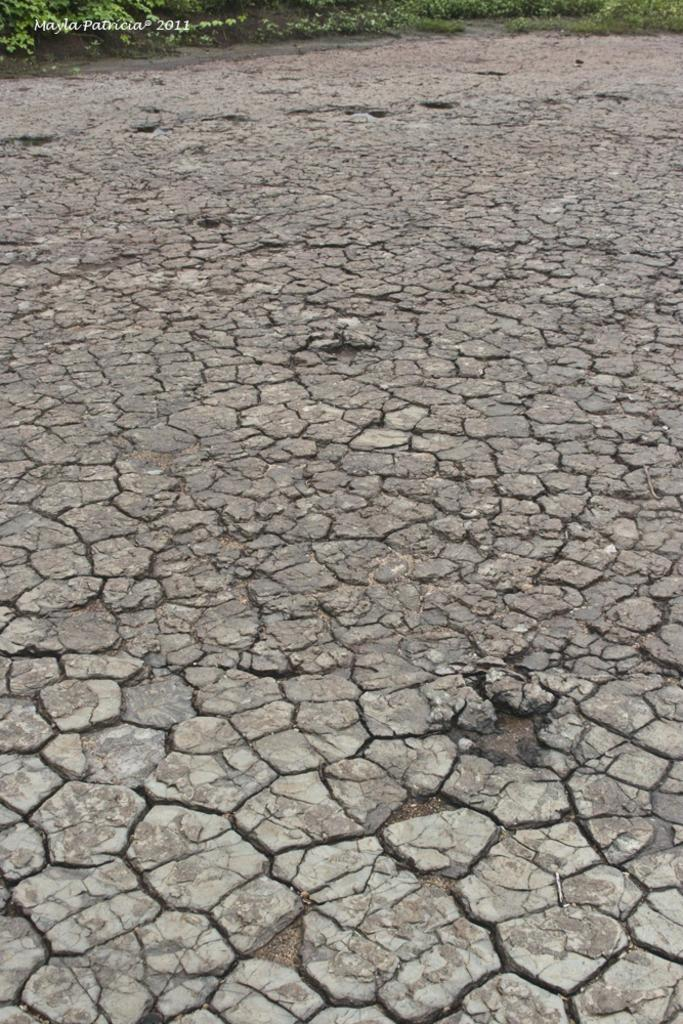What type of terrain is shown in the image? The image depicts dry land. What can be seen growing at the top of the image? There are plants visible at the top of the image. Is there any text present in the image? Yes, there is edited text in the image. Can you see a hook being used by the plants in the image? There is no hook present in the image, nor is it being used by the plants. 